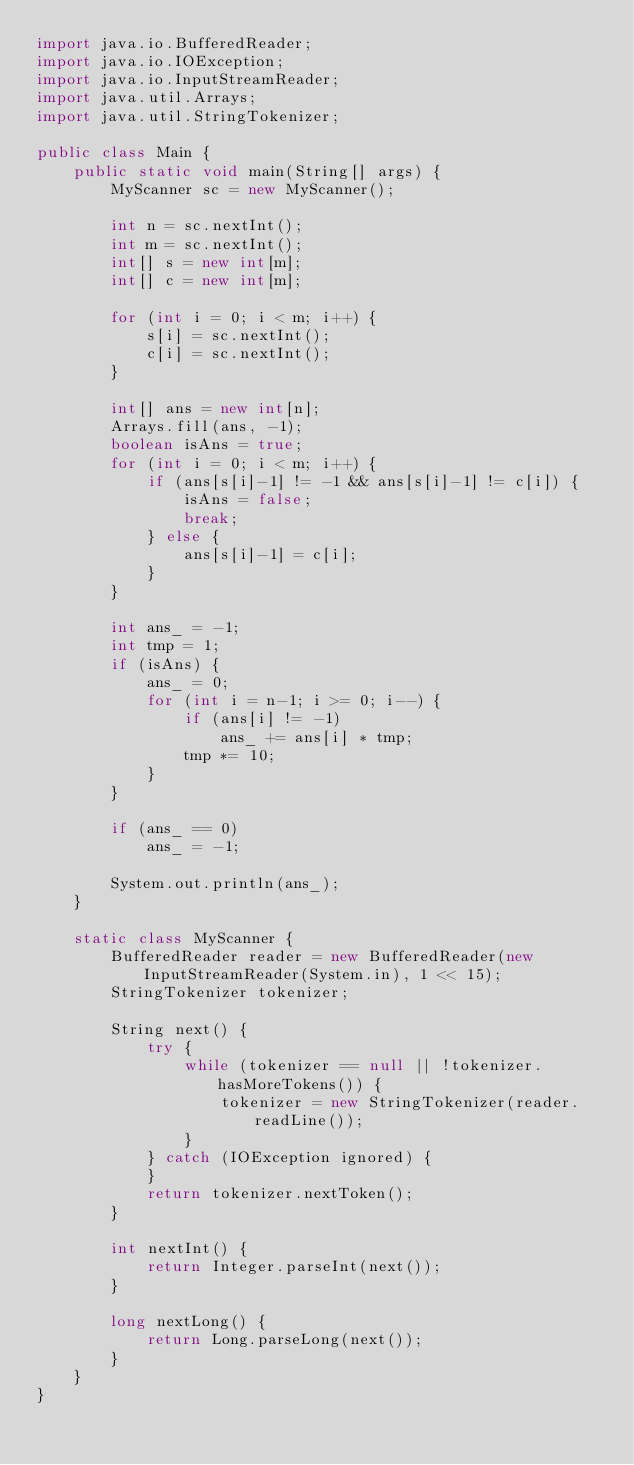<code> <loc_0><loc_0><loc_500><loc_500><_Java_>import java.io.BufferedReader;
import java.io.IOException;
import java.io.InputStreamReader;
import java.util.Arrays;
import java.util.StringTokenizer;

public class Main {
    public static void main(String[] args) {
        MyScanner sc = new MyScanner();

        int n = sc.nextInt();
        int m = sc.nextInt();
        int[] s = new int[m];
        int[] c = new int[m];

        for (int i = 0; i < m; i++) {
            s[i] = sc.nextInt();
            c[i] = sc.nextInt();
        }

        int[] ans = new int[n];
        Arrays.fill(ans, -1);
        boolean isAns = true;
        for (int i = 0; i < m; i++) {
            if (ans[s[i]-1] != -1 && ans[s[i]-1] != c[i]) {
                isAns = false;
                break;
            } else {
                ans[s[i]-1] = c[i];
            }
        }

        int ans_ = -1;
        int tmp = 1;
        if (isAns) {
            ans_ = 0;
            for (int i = n-1; i >= 0; i--) {
                if (ans[i] != -1)
                    ans_ += ans[i] * tmp;
                tmp *= 10;
            }
        }

        if (ans_ == 0)
            ans_ = -1;

        System.out.println(ans_);
    }

    static class MyScanner {
        BufferedReader reader = new BufferedReader(new InputStreamReader(System.in), 1 << 15);
        StringTokenizer tokenizer;

        String next() {
            try {
                while (tokenizer == null || !tokenizer.hasMoreTokens()) {
                    tokenizer = new StringTokenizer(reader.readLine());
                }
            } catch (IOException ignored) {
            }
            return tokenizer.nextToken();
        }

        int nextInt() {
            return Integer.parseInt(next());
        }

        long nextLong() {
            return Long.parseLong(next());
        }
    }
}</code> 